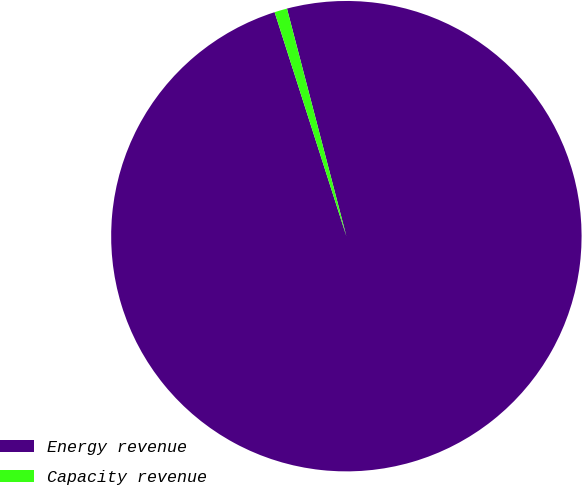Convert chart to OTSL. <chart><loc_0><loc_0><loc_500><loc_500><pie_chart><fcel>Energy revenue<fcel>Capacity revenue<nl><fcel>99.13%<fcel>0.87%<nl></chart> 